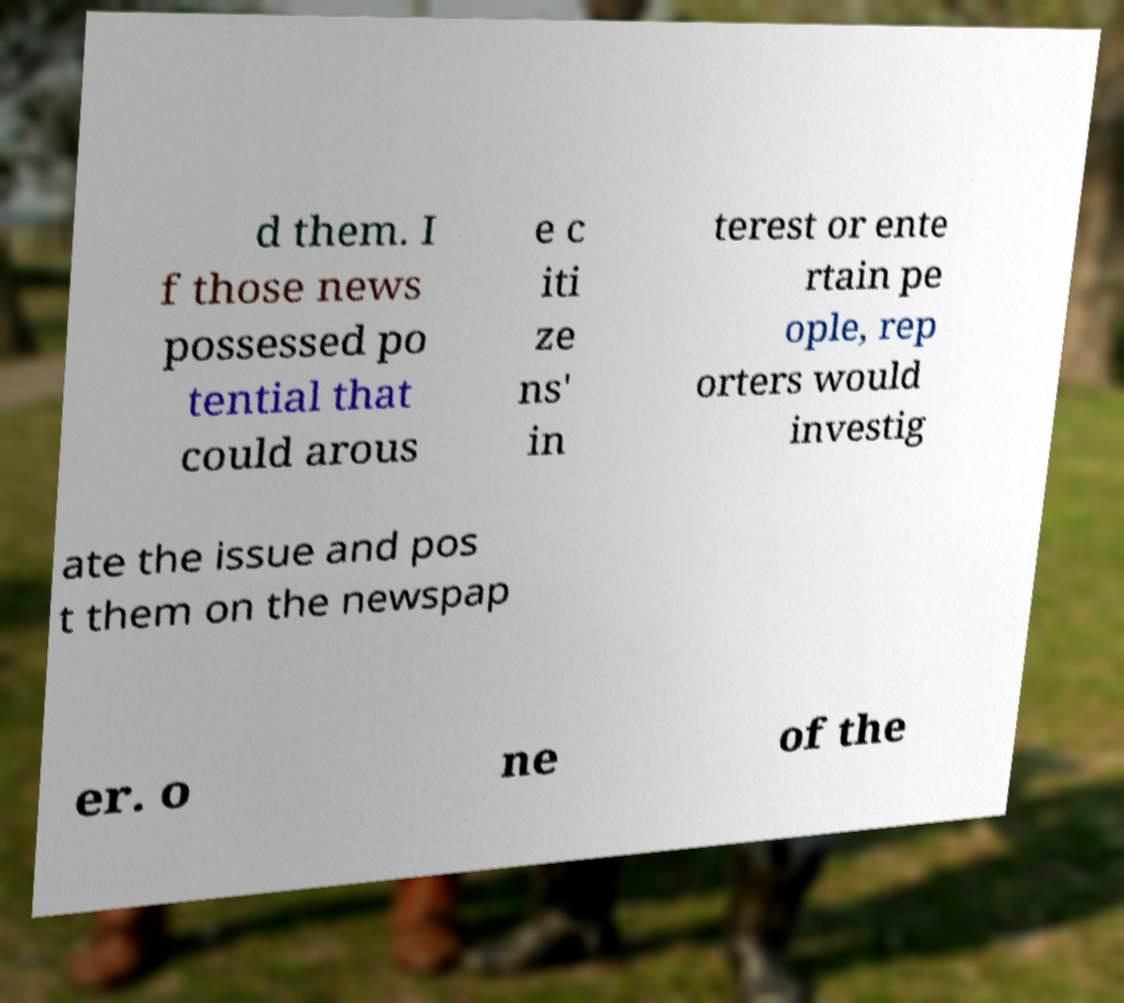Could you extract and type out the text from this image? d them. I f those news possessed po tential that could arous e c iti ze ns' in terest or ente rtain pe ople, rep orters would investig ate the issue and pos t them on the newspap er. o ne of the 